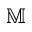<formula> <loc_0><loc_0><loc_500><loc_500>\mathbb { M }</formula> 